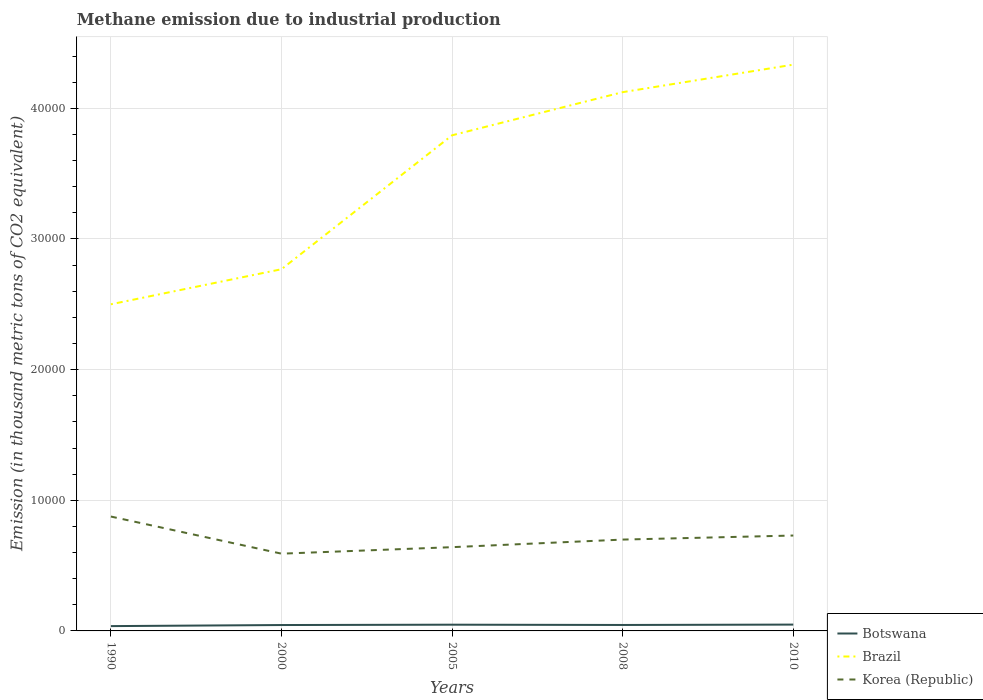How many different coloured lines are there?
Keep it short and to the point. 3. Does the line corresponding to Korea (Republic) intersect with the line corresponding to Brazil?
Keep it short and to the point. No. Across all years, what is the maximum amount of methane emitted in Botswana?
Provide a short and direct response. 367.9. What is the total amount of methane emitted in Brazil in the graph?
Ensure brevity in your answer.  -1.62e+04. What is the difference between the highest and the second highest amount of methane emitted in Brazil?
Give a very brief answer. 1.83e+04. How many years are there in the graph?
Make the answer very short. 5. What is the difference between two consecutive major ticks on the Y-axis?
Your response must be concise. 10000. Does the graph contain grids?
Keep it short and to the point. Yes. Where does the legend appear in the graph?
Provide a short and direct response. Bottom right. What is the title of the graph?
Give a very brief answer. Methane emission due to industrial production. Does "United Arab Emirates" appear as one of the legend labels in the graph?
Make the answer very short. No. What is the label or title of the X-axis?
Ensure brevity in your answer.  Years. What is the label or title of the Y-axis?
Offer a very short reply. Emission (in thousand metric tons of CO2 equivalent). What is the Emission (in thousand metric tons of CO2 equivalent) in Botswana in 1990?
Give a very brief answer. 367.9. What is the Emission (in thousand metric tons of CO2 equivalent) in Brazil in 1990?
Provide a short and direct response. 2.50e+04. What is the Emission (in thousand metric tons of CO2 equivalent) in Korea (Republic) in 1990?
Offer a very short reply. 8754.2. What is the Emission (in thousand metric tons of CO2 equivalent) of Botswana in 2000?
Your response must be concise. 451.3. What is the Emission (in thousand metric tons of CO2 equivalent) in Brazil in 2000?
Provide a short and direct response. 2.77e+04. What is the Emission (in thousand metric tons of CO2 equivalent) in Korea (Republic) in 2000?
Ensure brevity in your answer.  5912.8. What is the Emission (in thousand metric tons of CO2 equivalent) in Botswana in 2005?
Your response must be concise. 477.3. What is the Emission (in thousand metric tons of CO2 equivalent) of Brazil in 2005?
Provide a short and direct response. 3.79e+04. What is the Emission (in thousand metric tons of CO2 equivalent) of Korea (Republic) in 2005?
Offer a terse response. 6410.4. What is the Emission (in thousand metric tons of CO2 equivalent) in Botswana in 2008?
Your answer should be very brief. 455.6. What is the Emission (in thousand metric tons of CO2 equivalent) in Brazil in 2008?
Offer a very short reply. 4.12e+04. What is the Emission (in thousand metric tons of CO2 equivalent) in Korea (Republic) in 2008?
Your answer should be compact. 6990.7. What is the Emission (in thousand metric tons of CO2 equivalent) of Botswana in 2010?
Your response must be concise. 483.7. What is the Emission (in thousand metric tons of CO2 equivalent) in Brazil in 2010?
Offer a very short reply. 4.33e+04. What is the Emission (in thousand metric tons of CO2 equivalent) of Korea (Republic) in 2010?
Provide a short and direct response. 7301.2. Across all years, what is the maximum Emission (in thousand metric tons of CO2 equivalent) of Botswana?
Make the answer very short. 483.7. Across all years, what is the maximum Emission (in thousand metric tons of CO2 equivalent) of Brazil?
Provide a succinct answer. 4.33e+04. Across all years, what is the maximum Emission (in thousand metric tons of CO2 equivalent) in Korea (Republic)?
Your answer should be compact. 8754.2. Across all years, what is the minimum Emission (in thousand metric tons of CO2 equivalent) of Botswana?
Make the answer very short. 367.9. Across all years, what is the minimum Emission (in thousand metric tons of CO2 equivalent) of Brazil?
Keep it short and to the point. 2.50e+04. Across all years, what is the minimum Emission (in thousand metric tons of CO2 equivalent) of Korea (Republic)?
Provide a short and direct response. 5912.8. What is the total Emission (in thousand metric tons of CO2 equivalent) of Botswana in the graph?
Make the answer very short. 2235.8. What is the total Emission (in thousand metric tons of CO2 equivalent) in Brazil in the graph?
Your response must be concise. 1.75e+05. What is the total Emission (in thousand metric tons of CO2 equivalent) of Korea (Republic) in the graph?
Provide a short and direct response. 3.54e+04. What is the difference between the Emission (in thousand metric tons of CO2 equivalent) in Botswana in 1990 and that in 2000?
Keep it short and to the point. -83.4. What is the difference between the Emission (in thousand metric tons of CO2 equivalent) of Brazil in 1990 and that in 2000?
Give a very brief answer. -2683.2. What is the difference between the Emission (in thousand metric tons of CO2 equivalent) of Korea (Republic) in 1990 and that in 2000?
Provide a short and direct response. 2841.4. What is the difference between the Emission (in thousand metric tons of CO2 equivalent) in Botswana in 1990 and that in 2005?
Your response must be concise. -109.4. What is the difference between the Emission (in thousand metric tons of CO2 equivalent) of Brazil in 1990 and that in 2005?
Provide a short and direct response. -1.29e+04. What is the difference between the Emission (in thousand metric tons of CO2 equivalent) of Korea (Republic) in 1990 and that in 2005?
Keep it short and to the point. 2343.8. What is the difference between the Emission (in thousand metric tons of CO2 equivalent) in Botswana in 1990 and that in 2008?
Offer a terse response. -87.7. What is the difference between the Emission (in thousand metric tons of CO2 equivalent) of Brazil in 1990 and that in 2008?
Your answer should be compact. -1.62e+04. What is the difference between the Emission (in thousand metric tons of CO2 equivalent) of Korea (Republic) in 1990 and that in 2008?
Offer a terse response. 1763.5. What is the difference between the Emission (in thousand metric tons of CO2 equivalent) of Botswana in 1990 and that in 2010?
Your answer should be compact. -115.8. What is the difference between the Emission (in thousand metric tons of CO2 equivalent) of Brazil in 1990 and that in 2010?
Offer a very short reply. -1.83e+04. What is the difference between the Emission (in thousand metric tons of CO2 equivalent) in Korea (Republic) in 1990 and that in 2010?
Keep it short and to the point. 1453. What is the difference between the Emission (in thousand metric tons of CO2 equivalent) in Brazil in 2000 and that in 2005?
Provide a short and direct response. -1.02e+04. What is the difference between the Emission (in thousand metric tons of CO2 equivalent) of Korea (Republic) in 2000 and that in 2005?
Ensure brevity in your answer.  -497.6. What is the difference between the Emission (in thousand metric tons of CO2 equivalent) of Botswana in 2000 and that in 2008?
Keep it short and to the point. -4.3. What is the difference between the Emission (in thousand metric tons of CO2 equivalent) of Brazil in 2000 and that in 2008?
Give a very brief answer. -1.36e+04. What is the difference between the Emission (in thousand metric tons of CO2 equivalent) of Korea (Republic) in 2000 and that in 2008?
Provide a short and direct response. -1077.9. What is the difference between the Emission (in thousand metric tons of CO2 equivalent) of Botswana in 2000 and that in 2010?
Keep it short and to the point. -32.4. What is the difference between the Emission (in thousand metric tons of CO2 equivalent) in Brazil in 2000 and that in 2010?
Offer a terse response. -1.57e+04. What is the difference between the Emission (in thousand metric tons of CO2 equivalent) in Korea (Republic) in 2000 and that in 2010?
Keep it short and to the point. -1388.4. What is the difference between the Emission (in thousand metric tons of CO2 equivalent) of Botswana in 2005 and that in 2008?
Provide a succinct answer. 21.7. What is the difference between the Emission (in thousand metric tons of CO2 equivalent) in Brazil in 2005 and that in 2008?
Keep it short and to the point. -3302.1. What is the difference between the Emission (in thousand metric tons of CO2 equivalent) of Korea (Republic) in 2005 and that in 2008?
Keep it short and to the point. -580.3. What is the difference between the Emission (in thousand metric tons of CO2 equivalent) of Brazil in 2005 and that in 2010?
Provide a short and direct response. -5407.3. What is the difference between the Emission (in thousand metric tons of CO2 equivalent) in Korea (Republic) in 2005 and that in 2010?
Give a very brief answer. -890.8. What is the difference between the Emission (in thousand metric tons of CO2 equivalent) of Botswana in 2008 and that in 2010?
Provide a short and direct response. -28.1. What is the difference between the Emission (in thousand metric tons of CO2 equivalent) of Brazil in 2008 and that in 2010?
Make the answer very short. -2105.2. What is the difference between the Emission (in thousand metric tons of CO2 equivalent) of Korea (Republic) in 2008 and that in 2010?
Provide a short and direct response. -310.5. What is the difference between the Emission (in thousand metric tons of CO2 equivalent) in Botswana in 1990 and the Emission (in thousand metric tons of CO2 equivalent) in Brazil in 2000?
Your response must be concise. -2.73e+04. What is the difference between the Emission (in thousand metric tons of CO2 equivalent) in Botswana in 1990 and the Emission (in thousand metric tons of CO2 equivalent) in Korea (Republic) in 2000?
Provide a short and direct response. -5544.9. What is the difference between the Emission (in thousand metric tons of CO2 equivalent) in Brazil in 1990 and the Emission (in thousand metric tons of CO2 equivalent) in Korea (Republic) in 2000?
Your answer should be compact. 1.91e+04. What is the difference between the Emission (in thousand metric tons of CO2 equivalent) in Botswana in 1990 and the Emission (in thousand metric tons of CO2 equivalent) in Brazil in 2005?
Give a very brief answer. -3.76e+04. What is the difference between the Emission (in thousand metric tons of CO2 equivalent) of Botswana in 1990 and the Emission (in thousand metric tons of CO2 equivalent) of Korea (Republic) in 2005?
Offer a terse response. -6042.5. What is the difference between the Emission (in thousand metric tons of CO2 equivalent) of Brazil in 1990 and the Emission (in thousand metric tons of CO2 equivalent) of Korea (Republic) in 2005?
Keep it short and to the point. 1.86e+04. What is the difference between the Emission (in thousand metric tons of CO2 equivalent) in Botswana in 1990 and the Emission (in thousand metric tons of CO2 equivalent) in Brazil in 2008?
Offer a terse response. -4.09e+04. What is the difference between the Emission (in thousand metric tons of CO2 equivalent) of Botswana in 1990 and the Emission (in thousand metric tons of CO2 equivalent) of Korea (Republic) in 2008?
Make the answer very short. -6622.8. What is the difference between the Emission (in thousand metric tons of CO2 equivalent) in Brazil in 1990 and the Emission (in thousand metric tons of CO2 equivalent) in Korea (Republic) in 2008?
Offer a very short reply. 1.80e+04. What is the difference between the Emission (in thousand metric tons of CO2 equivalent) of Botswana in 1990 and the Emission (in thousand metric tons of CO2 equivalent) of Brazil in 2010?
Provide a short and direct response. -4.30e+04. What is the difference between the Emission (in thousand metric tons of CO2 equivalent) in Botswana in 1990 and the Emission (in thousand metric tons of CO2 equivalent) in Korea (Republic) in 2010?
Provide a succinct answer. -6933.3. What is the difference between the Emission (in thousand metric tons of CO2 equivalent) of Brazil in 1990 and the Emission (in thousand metric tons of CO2 equivalent) of Korea (Republic) in 2010?
Your response must be concise. 1.77e+04. What is the difference between the Emission (in thousand metric tons of CO2 equivalent) of Botswana in 2000 and the Emission (in thousand metric tons of CO2 equivalent) of Brazil in 2005?
Make the answer very short. -3.75e+04. What is the difference between the Emission (in thousand metric tons of CO2 equivalent) in Botswana in 2000 and the Emission (in thousand metric tons of CO2 equivalent) in Korea (Republic) in 2005?
Offer a very short reply. -5959.1. What is the difference between the Emission (in thousand metric tons of CO2 equivalent) of Brazil in 2000 and the Emission (in thousand metric tons of CO2 equivalent) of Korea (Republic) in 2005?
Your answer should be compact. 2.13e+04. What is the difference between the Emission (in thousand metric tons of CO2 equivalent) in Botswana in 2000 and the Emission (in thousand metric tons of CO2 equivalent) in Brazil in 2008?
Your answer should be compact. -4.08e+04. What is the difference between the Emission (in thousand metric tons of CO2 equivalent) in Botswana in 2000 and the Emission (in thousand metric tons of CO2 equivalent) in Korea (Republic) in 2008?
Your answer should be very brief. -6539.4. What is the difference between the Emission (in thousand metric tons of CO2 equivalent) in Brazil in 2000 and the Emission (in thousand metric tons of CO2 equivalent) in Korea (Republic) in 2008?
Your response must be concise. 2.07e+04. What is the difference between the Emission (in thousand metric tons of CO2 equivalent) in Botswana in 2000 and the Emission (in thousand metric tons of CO2 equivalent) in Brazil in 2010?
Offer a terse response. -4.29e+04. What is the difference between the Emission (in thousand metric tons of CO2 equivalent) in Botswana in 2000 and the Emission (in thousand metric tons of CO2 equivalent) in Korea (Republic) in 2010?
Give a very brief answer. -6849.9. What is the difference between the Emission (in thousand metric tons of CO2 equivalent) of Brazil in 2000 and the Emission (in thousand metric tons of CO2 equivalent) of Korea (Republic) in 2010?
Give a very brief answer. 2.04e+04. What is the difference between the Emission (in thousand metric tons of CO2 equivalent) of Botswana in 2005 and the Emission (in thousand metric tons of CO2 equivalent) of Brazil in 2008?
Provide a short and direct response. -4.08e+04. What is the difference between the Emission (in thousand metric tons of CO2 equivalent) in Botswana in 2005 and the Emission (in thousand metric tons of CO2 equivalent) in Korea (Republic) in 2008?
Keep it short and to the point. -6513.4. What is the difference between the Emission (in thousand metric tons of CO2 equivalent) of Brazil in 2005 and the Emission (in thousand metric tons of CO2 equivalent) of Korea (Republic) in 2008?
Provide a succinct answer. 3.09e+04. What is the difference between the Emission (in thousand metric tons of CO2 equivalent) of Botswana in 2005 and the Emission (in thousand metric tons of CO2 equivalent) of Brazil in 2010?
Your answer should be compact. -4.29e+04. What is the difference between the Emission (in thousand metric tons of CO2 equivalent) of Botswana in 2005 and the Emission (in thousand metric tons of CO2 equivalent) of Korea (Republic) in 2010?
Ensure brevity in your answer.  -6823.9. What is the difference between the Emission (in thousand metric tons of CO2 equivalent) of Brazil in 2005 and the Emission (in thousand metric tons of CO2 equivalent) of Korea (Republic) in 2010?
Ensure brevity in your answer.  3.06e+04. What is the difference between the Emission (in thousand metric tons of CO2 equivalent) of Botswana in 2008 and the Emission (in thousand metric tons of CO2 equivalent) of Brazil in 2010?
Provide a short and direct response. -4.29e+04. What is the difference between the Emission (in thousand metric tons of CO2 equivalent) in Botswana in 2008 and the Emission (in thousand metric tons of CO2 equivalent) in Korea (Republic) in 2010?
Ensure brevity in your answer.  -6845.6. What is the difference between the Emission (in thousand metric tons of CO2 equivalent) of Brazil in 2008 and the Emission (in thousand metric tons of CO2 equivalent) of Korea (Republic) in 2010?
Provide a short and direct response. 3.39e+04. What is the average Emission (in thousand metric tons of CO2 equivalent) of Botswana per year?
Provide a succinct answer. 447.16. What is the average Emission (in thousand metric tons of CO2 equivalent) of Brazil per year?
Your response must be concise. 3.50e+04. What is the average Emission (in thousand metric tons of CO2 equivalent) of Korea (Republic) per year?
Offer a very short reply. 7073.86. In the year 1990, what is the difference between the Emission (in thousand metric tons of CO2 equivalent) in Botswana and Emission (in thousand metric tons of CO2 equivalent) in Brazil?
Give a very brief answer. -2.46e+04. In the year 1990, what is the difference between the Emission (in thousand metric tons of CO2 equivalent) in Botswana and Emission (in thousand metric tons of CO2 equivalent) in Korea (Republic)?
Make the answer very short. -8386.3. In the year 1990, what is the difference between the Emission (in thousand metric tons of CO2 equivalent) in Brazil and Emission (in thousand metric tons of CO2 equivalent) in Korea (Republic)?
Offer a very short reply. 1.62e+04. In the year 2000, what is the difference between the Emission (in thousand metric tons of CO2 equivalent) of Botswana and Emission (in thousand metric tons of CO2 equivalent) of Brazil?
Provide a short and direct response. -2.72e+04. In the year 2000, what is the difference between the Emission (in thousand metric tons of CO2 equivalent) of Botswana and Emission (in thousand metric tons of CO2 equivalent) of Korea (Republic)?
Give a very brief answer. -5461.5. In the year 2000, what is the difference between the Emission (in thousand metric tons of CO2 equivalent) in Brazil and Emission (in thousand metric tons of CO2 equivalent) in Korea (Republic)?
Provide a short and direct response. 2.18e+04. In the year 2005, what is the difference between the Emission (in thousand metric tons of CO2 equivalent) of Botswana and Emission (in thousand metric tons of CO2 equivalent) of Brazil?
Offer a very short reply. -3.75e+04. In the year 2005, what is the difference between the Emission (in thousand metric tons of CO2 equivalent) of Botswana and Emission (in thousand metric tons of CO2 equivalent) of Korea (Republic)?
Offer a terse response. -5933.1. In the year 2005, what is the difference between the Emission (in thousand metric tons of CO2 equivalent) in Brazil and Emission (in thousand metric tons of CO2 equivalent) in Korea (Republic)?
Keep it short and to the point. 3.15e+04. In the year 2008, what is the difference between the Emission (in thousand metric tons of CO2 equivalent) in Botswana and Emission (in thousand metric tons of CO2 equivalent) in Brazil?
Your answer should be compact. -4.08e+04. In the year 2008, what is the difference between the Emission (in thousand metric tons of CO2 equivalent) of Botswana and Emission (in thousand metric tons of CO2 equivalent) of Korea (Republic)?
Offer a very short reply. -6535.1. In the year 2008, what is the difference between the Emission (in thousand metric tons of CO2 equivalent) of Brazil and Emission (in thousand metric tons of CO2 equivalent) of Korea (Republic)?
Your response must be concise. 3.42e+04. In the year 2010, what is the difference between the Emission (in thousand metric tons of CO2 equivalent) in Botswana and Emission (in thousand metric tons of CO2 equivalent) in Brazil?
Make the answer very short. -4.29e+04. In the year 2010, what is the difference between the Emission (in thousand metric tons of CO2 equivalent) in Botswana and Emission (in thousand metric tons of CO2 equivalent) in Korea (Republic)?
Offer a very short reply. -6817.5. In the year 2010, what is the difference between the Emission (in thousand metric tons of CO2 equivalent) of Brazil and Emission (in thousand metric tons of CO2 equivalent) of Korea (Republic)?
Your answer should be compact. 3.60e+04. What is the ratio of the Emission (in thousand metric tons of CO2 equivalent) in Botswana in 1990 to that in 2000?
Your answer should be very brief. 0.82. What is the ratio of the Emission (in thousand metric tons of CO2 equivalent) of Brazil in 1990 to that in 2000?
Your answer should be compact. 0.9. What is the ratio of the Emission (in thousand metric tons of CO2 equivalent) of Korea (Republic) in 1990 to that in 2000?
Your answer should be very brief. 1.48. What is the ratio of the Emission (in thousand metric tons of CO2 equivalent) of Botswana in 1990 to that in 2005?
Keep it short and to the point. 0.77. What is the ratio of the Emission (in thousand metric tons of CO2 equivalent) of Brazil in 1990 to that in 2005?
Keep it short and to the point. 0.66. What is the ratio of the Emission (in thousand metric tons of CO2 equivalent) of Korea (Republic) in 1990 to that in 2005?
Ensure brevity in your answer.  1.37. What is the ratio of the Emission (in thousand metric tons of CO2 equivalent) of Botswana in 1990 to that in 2008?
Give a very brief answer. 0.81. What is the ratio of the Emission (in thousand metric tons of CO2 equivalent) in Brazil in 1990 to that in 2008?
Provide a short and direct response. 0.61. What is the ratio of the Emission (in thousand metric tons of CO2 equivalent) in Korea (Republic) in 1990 to that in 2008?
Make the answer very short. 1.25. What is the ratio of the Emission (in thousand metric tons of CO2 equivalent) of Botswana in 1990 to that in 2010?
Give a very brief answer. 0.76. What is the ratio of the Emission (in thousand metric tons of CO2 equivalent) in Brazil in 1990 to that in 2010?
Make the answer very short. 0.58. What is the ratio of the Emission (in thousand metric tons of CO2 equivalent) of Korea (Republic) in 1990 to that in 2010?
Offer a very short reply. 1.2. What is the ratio of the Emission (in thousand metric tons of CO2 equivalent) of Botswana in 2000 to that in 2005?
Make the answer very short. 0.95. What is the ratio of the Emission (in thousand metric tons of CO2 equivalent) in Brazil in 2000 to that in 2005?
Make the answer very short. 0.73. What is the ratio of the Emission (in thousand metric tons of CO2 equivalent) of Korea (Republic) in 2000 to that in 2005?
Ensure brevity in your answer.  0.92. What is the ratio of the Emission (in thousand metric tons of CO2 equivalent) in Botswana in 2000 to that in 2008?
Provide a succinct answer. 0.99. What is the ratio of the Emission (in thousand metric tons of CO2 equivalent) of Brazil in 2000 to that in 2008?
Your answer should be very brief. 0.67. What is the ratio of the Emission (in thousand metric tons of CO2 equivalent) of Korea (Republic) in 2000 to that in 2008?
Your answer should be very brief. 0.85. What is the ratio of the Emission (in thousand metric tons of CO2 equivalent) in Botswana in 2000 to that in 2010?
Offer a very short reply. 0.93. What is the ratio of the Emission (in thousand metric tons of CO2 equivalent) in Brazil in 2000 to that in 2010?
Offer a terse response. 0.64. What is the ratio of the Emission (in thousand metric tons of CO2 equivalent) of Korea (Republic) in 2000 to that in 2010?
Offer a terse response. 0.81. What is the ratio of the Emission (in thousand metric tons of CO2 equivalent) in Botswana in 2005 to that in 2008?
Keep it short and to the point. 1.05. What is the ratio of the Emission (in thousand metric tons of CO2 equivalent) in Brazil in 2005 to that in 2008?
Offer a terse response. 0.92. What is the ratio of the Emission (in thousand metric tons of CO2 equivalent) in Korea (Republic) in 2005 to that in 2008?
Provide a succinct answer. 0.92. What is the ratio of the Emission (in thousand metric tons of CO2 equivalent) in Botswana in 2005 to that in 2010?
Provide a succinct answer. 0.99. What is the ratio of the Emission (in thousand metric tons of CO2 equivalent) of Brazil in 2005 to that in 2010?
Provide a short and direct response. 0.88. What is the ratio of the Emission (in thousand metric tons of CO2 equivalent) of Korea (Republic) in 2005 to that in 2010?
Your answer should be very brief. 0.88. What is the ratio of the Emission (in thousand metric tons of CO2 equivalent) of Botswana in 2008 to that in 2010?
Make the answer very short. 0.94. What is the ratio of the Emission (in thousand metric tons of CO2 equivalent) of Brazil in 2008 to that in 2010?
Ensure brevity in your answer.  0.95. What is the ratio of the Emission (in thousand metric tons of CO2 equivalent) of Korea (Republic) in 2008 to that in 2010?
Provide a short and direct response. 0.96. What is the difference between the highest and the second highest Emission (in thousand metric tons of CO2 equivalent) of Botswana?
Make the answer very short. 6.4. What is the difference between the highest and the second highest Emission (in thousand metric tons of CO2 equivalent) in Brazil?
Give a very brief answer. 2105.2. What is the difference between the highest and the second highest Emission (in thousand metric tons of CO2 equivalent) in Korea (Republic)?
Keep it short and to the point. 1453. What is the difference between the highest and the lowest Emission (in thousand metric tons of CO2 equivalent) in Botswana?
Offer a terse response. 115.8. What is the difference between the highest and the lowest Emission (in thousand metric tons of CO2 equivalent) of Brazil?
Ensure brevity in your answer.  1.83e+04. What is the difference between the highest and the lowest Emission (in thousand metric tons of CO2 equivalent) in Korea (Republic)?
Give a very brief answer. 2841.4. 